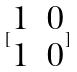<formula> <loc_0><loc_0><loc_500><loc_500>[ \begin{matrix} 1 & 0 \\ 1 & 0 \end{matrix} ]</formula> 